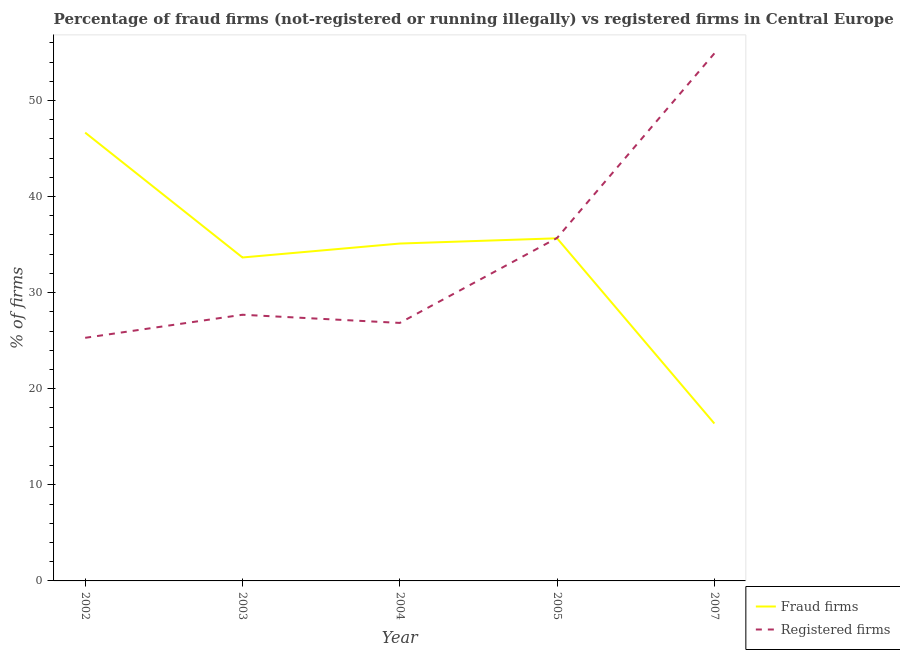How many different coloured lines are there?
Make the answer very short. 2. Is the number of lines equal to the number of legend labels?
Make the answer very short. Yes. What is the percentage of fraud firms in 2007?
Your answer should be very brief. 16.38. Across all years, what is the maximum percentage of fraud firms?
Your answer should be compact. 46.65. Across all years, what is the minimum percentage of registered firms?
Your answer should be very brief. 25.3. In which year was the percentage of fraud firms maximum?
Your answer should be very brief. 2002. What is the total percentage of fraud firms in the graph?
Your response must be concise. 167.46. What is the difference between the percentage of fraud firms in 2003 and that in 2004?
Offer a terse response. -1.45. What is the difference between the percentage of fraud firms in 2003 and the percentage of registered firms in 2002?
Your answer should be very brief. 8.36. What is the average percentage of registered firms per year?
Your response must be concise. 34.09. In the year 2004, what is the difference between the percentage of fraud firms and percentage of registered firms?
Offer a terse response. 8.26. In how many years, is the percentage of registered firms greater than 10 %?
Provide a succinct answer. 5. What is the ratio of the percentage of registered firms in 2002 to that in 2005?
Offer a terse response. 0.71. Is the percentage of registered firms in 2004 less than that in 2005?
Provide a short and direct response. Yes. Is the difference between the percentage of fraud firms in 2002 and 2007 greater than the difference between the percentage of registered firms in 2002 and 2007?
Provide a short and direct response. Yes. What is the difference between the highest and the second highest percentage of registered firms?
Keep it short and to the point. 19.21. What is the difference between the highest and the lowest percentage of fraud firms?
Offer a very short reply. 30.27. Does the percentage of registered firms monotonically increase over the years?
Make the answer very short. No. What is the difference between two consecutive major ticks on the Y-axis?
Your answer should be compact. 10. Does the graph contain any zero values?
Your answer should be very brief. No. Where does the legend appear in the graph?
Your response must be concise. Bottom right. How many legend labels are there?
Your answer should be very brief. 2. What is the title of the graph?
Your response must be concise. Percentage of fraud firms (not-registered or running illegally) vs registered firms in Central Europe. What is the label or title of the Y-axis?
Keep it short and to the point. % of firms. What is the % of firms in Fraud firms in 2002?
Offer a terse response. 46.65. What is the % of firms in Registered firms in 2002?
Ensure brevity in your answer.  25.3. What is the % of firms in Fraud firms in 2003?
Your answer should be compact. 33.66. What is the % of firms of Registered firms in 2003?
Give a very brief answer. 27.7. What is the % of firms of Fraud firms in 2004?
Your answer should be very brief. 35.11. What is the % of firms of Registered firms in 2004?
Ensure brevity in your answer.  26.85. What is the % of firms in Fraud firms in 2005?
Give a very brief answer. 35.66. What is the % of firms in Registered firms in 2005?
Ensure brevity in your answer.  35.69. What is the % of firms in Fraud firms in 2007?
Make the answer very short. 16.38. What is the % of firms in Registered firms in 2007?
Your response must be concise. 54.9. Across all years, what is the maximum % of firms in Fraud firms?
Provide a succinct answer. 46.65. Across all years, what is the maximum % of firms in Registered firms?
Give a very brief answer. 54.9. Across all years, what is the minimum % of firms in Fraud firms?
Offer a very short reply. 16.38. Across all years, what is the minimum % of firms of Registered firms?
Keep it short and to the point. 25.3. What is the total % of firms of Fraud firms in the graph?
Make the answer very short. 167.46. What is the total % of firms in Registered firms in the graph?
Make the answer very short. 170.44. What is the difference between the % of firms of Fraud firms in 2002 and that in 2003?
Your response must be concise. 12.99. What is the difference between the % of firms in Registered firms in 2002 and that in 2003?
Give a very brief answer. -2.4. What is the difference between the % of firms of Fraud firms in 2002 and that in 2004?
Offer a very short reply. 11.54. What is the difference between the % of firms in Registered firms in 2002 and that in 2004?
Keep it short and to the point. -1.55. What is the difference between the % of firms of Fraud firms in 2002 and that in 2005?
Provide a succinct answer. 11. What is the difference between the % of firms of Registered firms in 2002 and that in 2005?
Your answer should be very brief. -10.39. What is the difference between the % of firms of Fraud firms in 2002 and that in 2007?
Offer a terse response. 30.27. What is the difference between the % of firms in Registered firms in 2002 and that in 2007?
Provide a succinct answer. -29.6. What is the difference between the % of firms in Fraud firms in 2003 and that in 2004?
Give a very brief answer. -1.45. What is the difference between the % of firms of Registered firms in 2003 and that in 2004?
Ensure brevity in your answer.  0.85. What is the difference between the % of firms in Fraud firms in 2003 and that in 2005?
Your answer should be compact. -2. What is the difference between the % of firms of Registered firms in 2003 and that in 2005?
Your answer should be compact. -7.99. What is the difference between the % of firms of Fraud firms in 2003 and that in 2007?
Make the answer very short. 17.28. What is the difference between the % of firms in Registered firms in 2003 and that in 2007?
Offer a terse response. -27.2. What is the difference between the % of firms of Fraud firms in 2004 and that in 2005?
Provide a short and direct response. -0.55. What is the difference between the % of firms in Registered firms in 2004 and that in 2005?
Give a very brief answer. -8.84. What is the difference between the % of firms in Fraud firms in 2004 and that in 2007?
Ensure brevity in your answer.  18.73. What is the difference between the % of firms in Registered firms in 2004 and that in 2007?
Make the answer very short. -28.05. What is the difference between the % of firms in Fraud firms in 2005 and that in 2007?
Your response must be concise. 19.28. What is the difference between the % of firms in Registered firms in 2005 and that in 2007?
Your answer should be very brief. -19.21. What is the difference between the % of firms of Fraud firms in 2002 and the % of firms of Registered firms in 2003?
Make the answer very short. 18.95. What is the difference between the % of firms in Fraud firms in 2002 and the % of firms in Registered firms in 2004?
Your response must be concise. 19.8. What is the difference between the % of firms in Fraud firms in 2002 and the % of firms in Registered firms in 2005?
Offer a very short reply. 10.96. What is the difference between the % of firms of Fraud firms in 2002 and the % of firms of Registered firms in 2007?
Provide a short and direct response. -8.25. What is the difference between the % of firms in Fraud firms in 2003 and the % of firms in Registered firms in 2004?
Your answer should be compact. 6.81. What is the difference between the % of firms of Fraud firms in 2003 and the % of firms of Registered firms in 2005?
Offer a terse response. -2.03. What is the difference between the % of firms of Fraud firms in 2003 and the % of firms of Registered firms in 2007?
Provide a succinct answer. -21.24. What is the difference between the % of firms of Fraud firms in 2004 and the % of firms of Registered firms in 2005?
Provide a short and direct response. -0.58. What is the difference between the % of firms of Fraud firms in 2004 and the % of firms of Registered firms in 2007?
Provide a short and direct response. -19.79. What is the difference between the % of firms of Fraud firms in 2005 and the % of firms of Registered firms in 2007?
Your answer should be very brief. -19.24. What is the average % of firms in Fraud firms per year?
Your response must be concise. 33.49. What is the average % of firms in Registered firms per year?
Make the answer very short. 34.09. In the year 2002, what is the difference between the % of firms in Fraud firms and % of firms in Registered firms?
Offer a very short reply. 21.35. In the year 2003, what is the difference between the % of firms in Fraud firms and % of firms in Registered firms?
Make the answer very short. 5.96. In the year 2004, what is the difference between the % of firms in Fraud firms and % of firms in Registered firms?
Provide a succinct answer. 8.26. In the year 2005, what is the difference between the % of firms of Fraud firms and % of firms of Registered firms?
Keep it short and to the point. -0.03. In the year 2007, what is the difference between the % of firms in Fraud firms and % of firms in Registered firms?
Make the answer very short. -38.52. What is the ratio of the % of firms of Fraud firms in 2002 to that in 2003?
Provide a succinct answer. 1.39. What is the ratio of the % of firms in Registered firms in 2002 to that in 2003?
Offer a very short reply. 0.91. What is the ratio of the % of firms of Fraud firms in 2002 to that in 2004?
Your answer should be compact. 1.33. What is the ratio of the % of firms in Registered firms in 2002 to that in 2004?
Your answer should be compact. 0.94. What is the ratio of the % of firms in Fraud firms in 2002 to that in 2005?
Provide a succinct answer. 1.31. What is the ratio of the % of firms of Registered firms in 2002 to that in 2005?
Provide a succinct answer. 0.71. What is the ratio of the % of firms in Fraud firms in 2002 to that in 2007?
Ensure brevity in your answer.  2.85. What is the ratio of the % of firms in Registered firms in 2002 to that in 2007?
Your answer should be very brief. 0.46. What is the ratio of the % of firms of Fraud firms in 2003 to that in 2004?
Your answer should be compact. 0.96. What is the ratio of the % of firms in Registered firms in 2003 to that in 2004?
Your answer should be very brief. 1.03. What is the ratio of the % of firms in Fraud firms in 2003 to that in 2005?
Make the answer very short. 0.94. What is the ratio of the % of firms of Registered firms in 2003 to that in 2005?
Your response must be concise. 0.78. What is the ratio of the % of firms of Fraud firms in 2003 to that in 2007?
Your answer should be very brief. 2.05. What is the ratio of the % of firms in Registered firms in 2003 to that in 2007?
Offer a very short reply. 0.5. What is the ratio of the % of firms of Fraud firms in 2004 to that in 2005?
Your response must be concise. 0.98. What is the ratio of the % of firms of Registered firms in 2004 to that in 2005?
Make the answer very short. 0.75. What is the ratio of the % of firms of Fraud firms in 2004 to that in 2007?
Your answer should be compact. 2.14. What is the ratio of the % of firms in Registered firms in 2004 to that in 2007?
Keep it short and to the point. 0.49. What is the ratio of the % of firms in Fraud firms in 2005 to that in 2007?
Your response must be concise. 2.18. What is the ratio of the % of firms in Registered firms in 2005 to that in 2007?
Make the answer very short. 0.65. What is the difference between the highest and the second highest % of firms of Fraud firms?
Ensure brevity in your answer.  11. What is the difference between the highest and the second highest % of firms of Registered firms?
Your answer should be compact. 19.21. What is the difference between the highest and the lowest % of firms of Fraud firms?
Offer a terse response. 30.27. What is the difference between the highest and the lowest % of firms in Registered firms?
Provide a short and direct response. 29.6. 